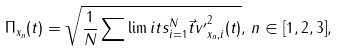<formula> <loc_0><loc_0><loc_500><loc_500>\Pi _ { x _ { n } } ( t ) = \sqrt { \frac { 1 } { N } \sum \lim i t s _ { i = 1 } ^ { N } { \vec { t } { v } ^ { \prime } } _ { x _ { n } , i } ^ { 2 } ( t ) } , \, n \in [ 1 , 2 , 3 ] ,</formula> 